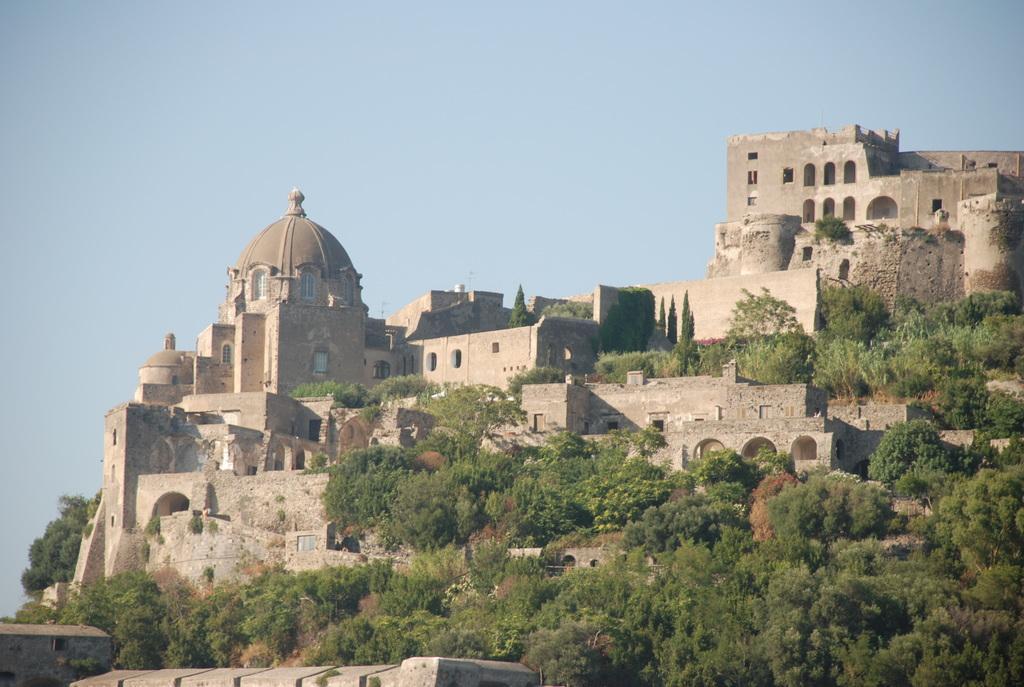In one or two sentences, can you explain what this image depicts? In this image I can see few trees in green color, background I can see few buildings in brown and cream color and the sky is in blue color. 